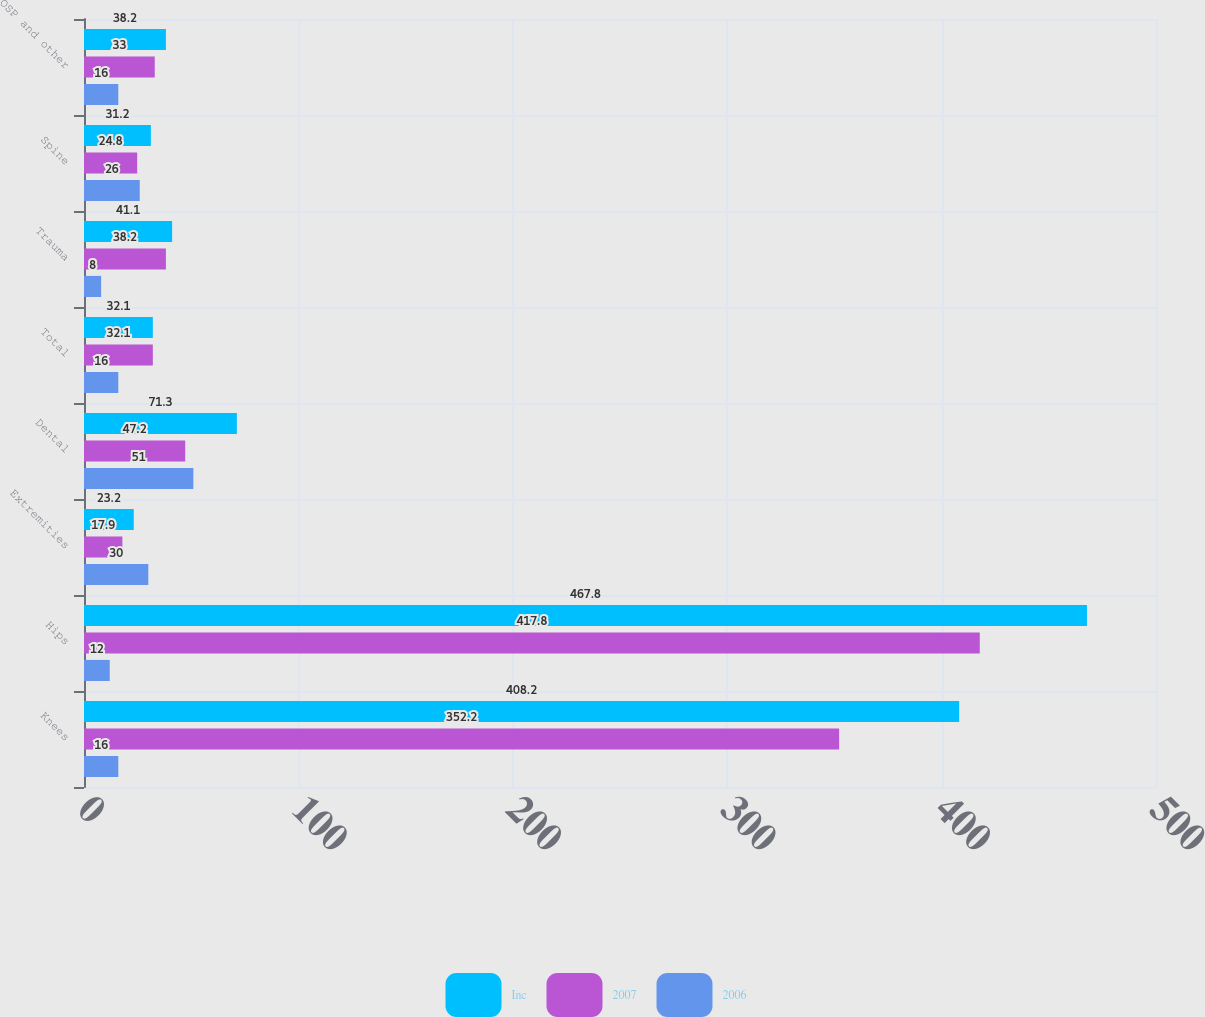Convert chart. <chart><loc_0><loc_0><loc_500><loc_500><stacked_bar_chart><ecel><fcel>Knees<fcel>Hips<fcel>Extremities<fcel>Dental<fcel>Total<fcel>Trauma<fcel>Spine<fcel>OSP and other<nl><fcel>Inc<fcel>408.2<fcel>467.8<fcel>23.2<fcel>71.3<fcel>32.1<fcel>41.1<fcel>31.2<fcel>38.2<nl><fcel>2007<fcel>352.2<fcel>417.8<fcel>17.9<fcel>47.2<fcel>32.1<fcel>38.2<fcel>24.8<fcel>33<nl><fcel>2006<fcel>16<fcel>12<fcel>30<fcel>51<fcel>16<fcel>8<fcel>26<fcel>16<nl></chart> 